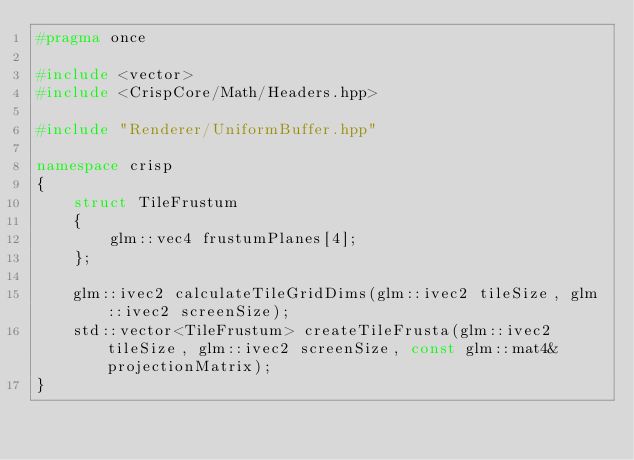Convert code to text. <code><loc_0><loc_0><loc_500><loc_500><_C++_>#pragma once

#include <vector>
#include <CrispCore/Math/Headers.hpp>

#include "Renderer/UniformBuffer.hpp"

namespace crisp
{
    struct TileFrustum
    {
        glm::vec4 frustumPlanes[4];
    };

    glm::ivec2 calculateTileGridDims(glm::ivec2 tileSize, glm::ivec2 screenSize);
    std::vector<TileFrustum> createTileFrusta(glm::ivec2 tileSize, glm::ivec2 screenSize, const glm::mat4& projectionMatrix);
}</code> 